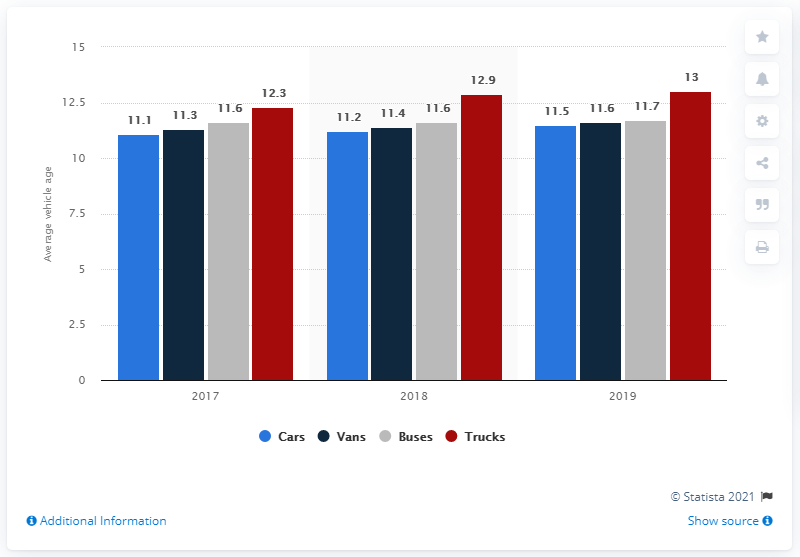Mention a couple of crucial points in this snapshot. In 2019, the highest age of trucks on the road was 13 years. In 2017, the average age of vans was higher than in 2019, with a difference of approximately -0.3 years. 